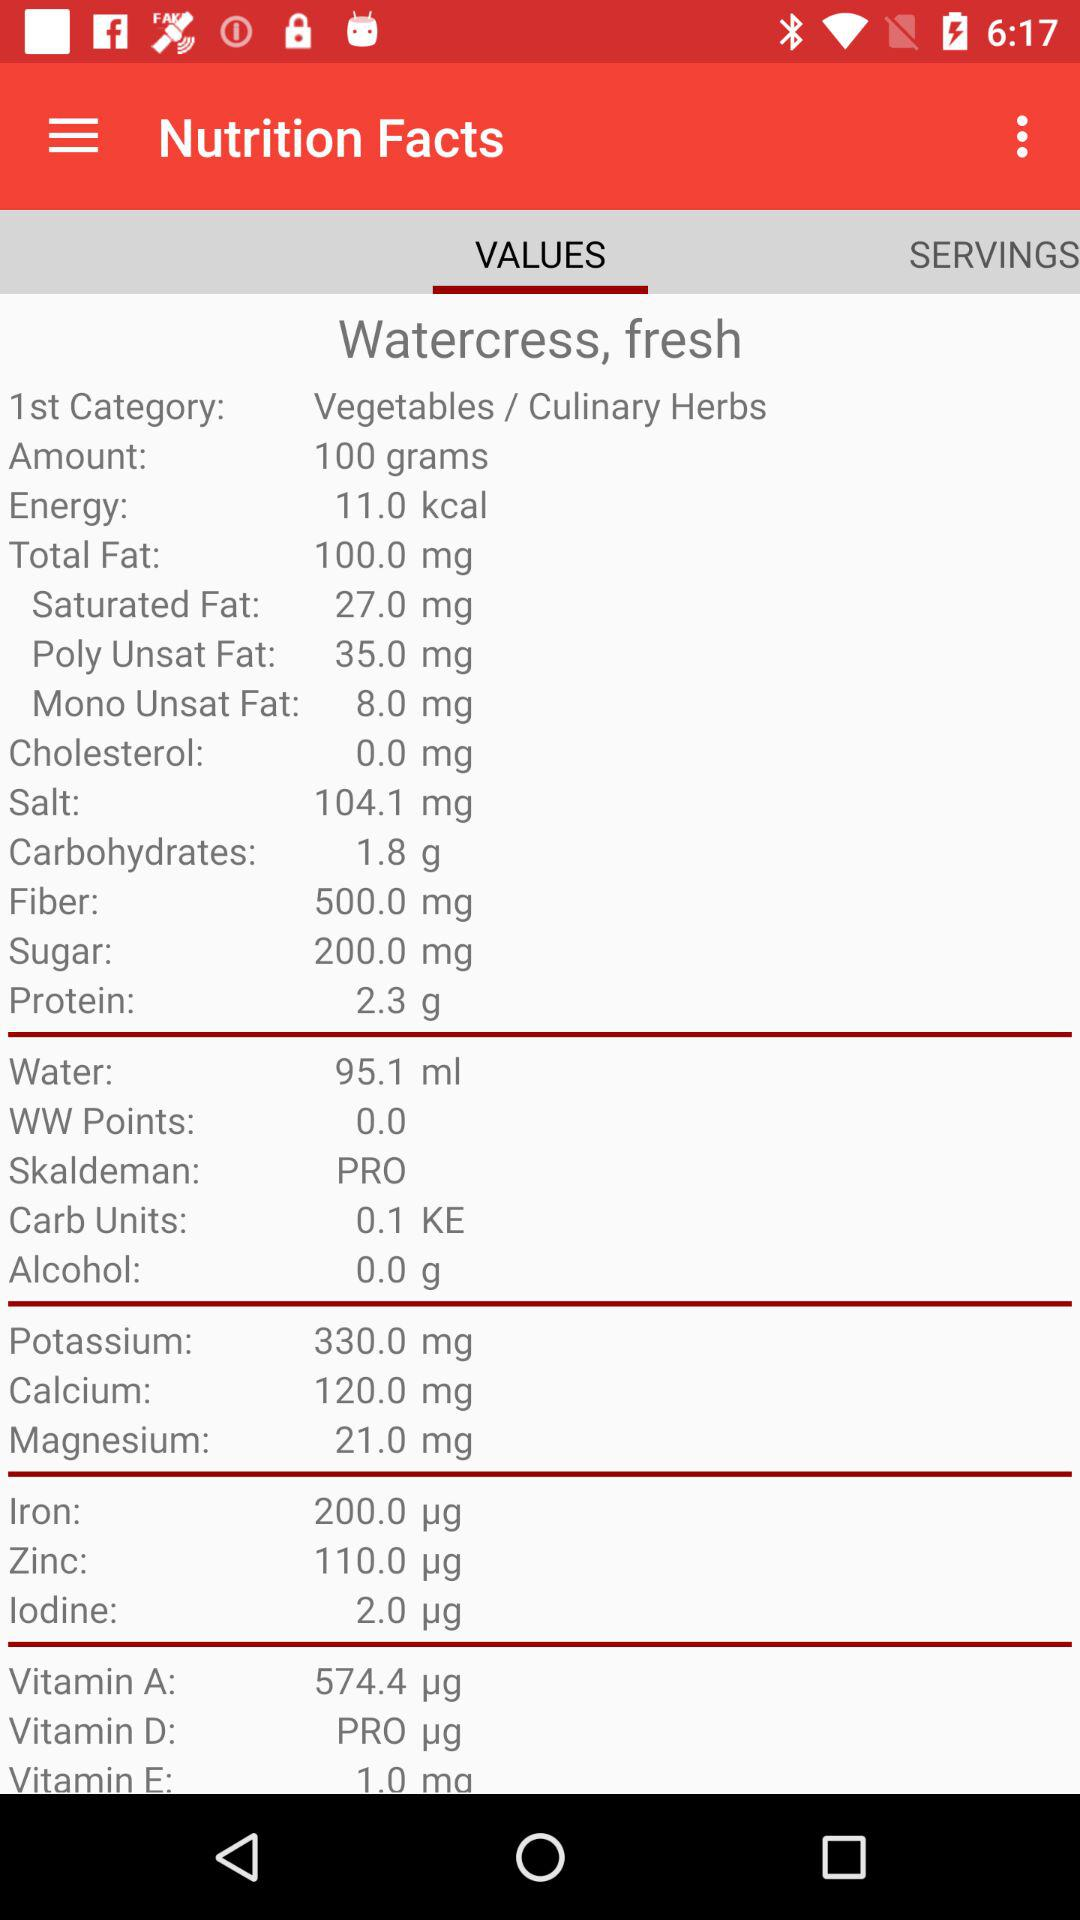What is the amount of salt in "Vegetables / Culinary Herbs"? The amount of salt in "Vegetables / Culinary Herbs" is 104.1 mg. 